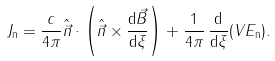Convert formula to latex. <formula><loc_0><loc_0><loc_500><loc_500>J _ { \mathrm n } = \frac { c } { 4 \pi } \hat { \vec { n } } \cdot \left ( \hat { \vec { n } } \times \frac { \mathrm d \vec { B } } { \mathrm d \xi } \right ) + \frac { 1 } { 4 \pi } \, \frac { \mathrm d } { \mathrm d \xi } ( V E _ { \mathrm n } ) .</formula> 